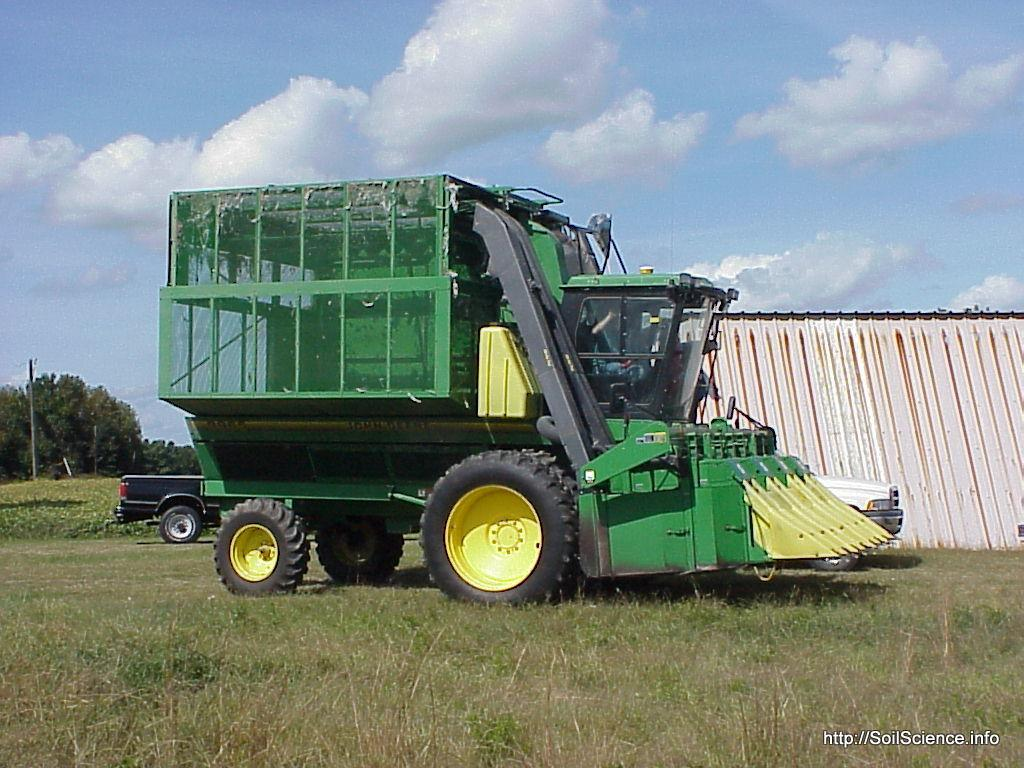What types of objects can be seen in the image? There are vehicles in the image. What natural elements are present in the image? There are trees and grass in the image. What is visible in the background of the image? The sky is visible in the background of the image. Can you describe any additional features of the image? There is a watermark on the image. What is the smell of the grass in the image? The image is a photograph, and as such, it does not have a smell. The question of the smell of the grass cannot be answered definitively from the image. 